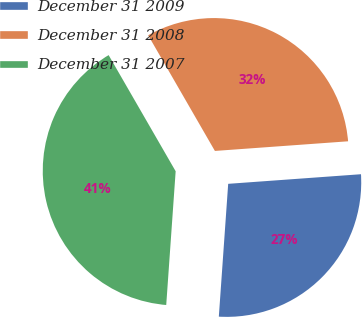Convert chart. <chart><loc_0><loc_0><loc_500><loc_500><pie_chart><fcel>December 31 2009<fcel>December 31 2008<fcel>December 31 2007<nl><fcel>27.27%<fcel>32.18%<fcel>40.55%<nl></chart> 